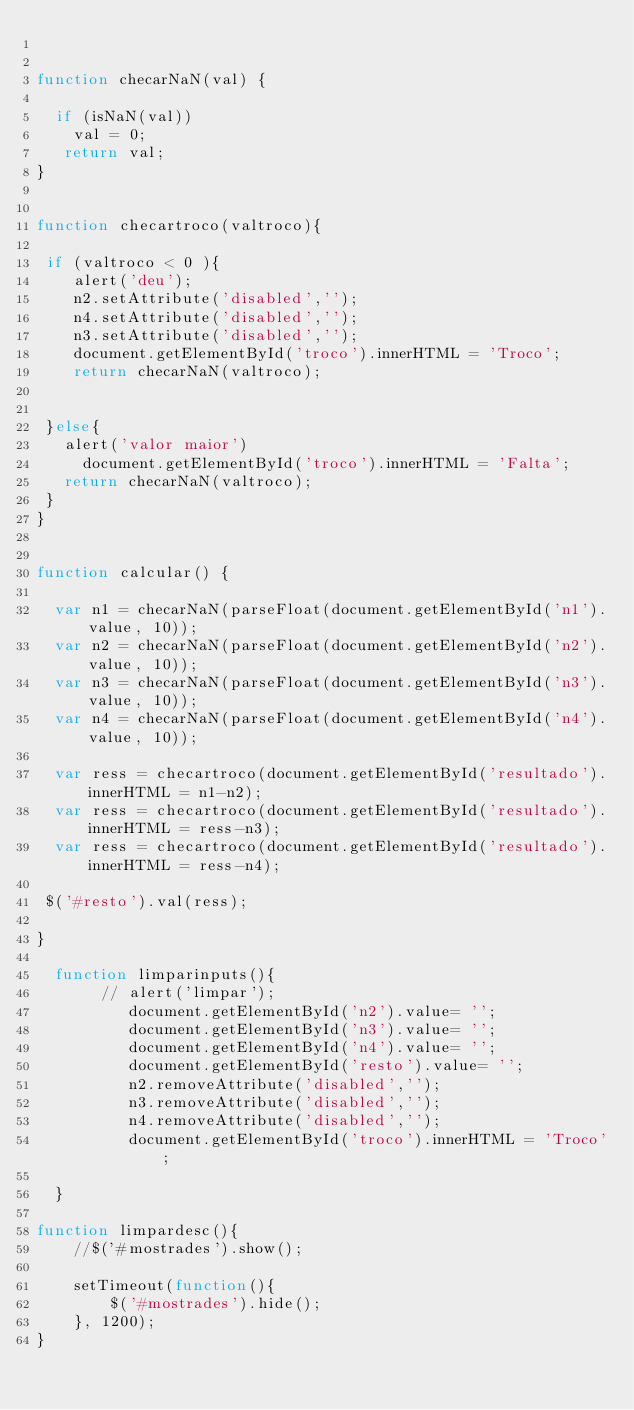Convert code to text. <code><loc_0><loc_0><loc_500><loc_500><_JavaScript_>
  
function checarNaN(val) {
  
  if (isNaN(val))
    val = 0;
   return val;
}


function checartroco(valtroco){
  
 if (valtroco < 0 ){
    alert('deu');
    n2.setAttribute('disabled','');
    n4.setAttribute('disabled','');
    n3.setAttribute('disabled','');
    document.getElementById('troco').innerHTML = 'Troco';
    return checarNaN(valtroco);
 
    
 }else{
   alert('valor maior') 
     document.getElementById('troco').innerHTML = 'Falta';
   return checarNaN(valtroco);
 }
}


function calcular() {

  var n1 = checarNaN(parseFloat(document.getElementById('n1').value, 10));
  var n2 = checarNaN(parseFloat(document.getElementById('n2').value, 10));
  var n3 = checarNaN(parseFloat(document.getElementById('n3').value, 10));
  var n4 = checarNaN(parseFloat(document.getElementById('n4').value, 10));

  var ress = checartroco(document.getElementById('resultado').innerHTML = n1-n2);
  var ress = checartroco(document.getElementById('resultado').innerHTML = ress-n3);
  var ress = checartroco(document.getElementById('resultado').innerHTML = ress-n4);

 $('#resto').val(ress);
  
}
   
  function limparinputs(){
       // alert('limpar');
          document.getElementById('n2').value= '';
          document.getElementById('n3').value= '';
          document.getElementById('n4').value= '';
          document.getElementById('resto').value= '';
          n2.removeAttribute('disabled','');
          n3.removeAttribute('disabled','');
          n4.removeAttribute('disabled','');
          document.getElementById('troco').innerHTML = 'Troco';
       
  }

function limpardesc(){
    //$('#mostrades').show();

    setTimeout(function(){ 
        $('#mostrades').hide();
    }, 1200);
}
 


</code> 